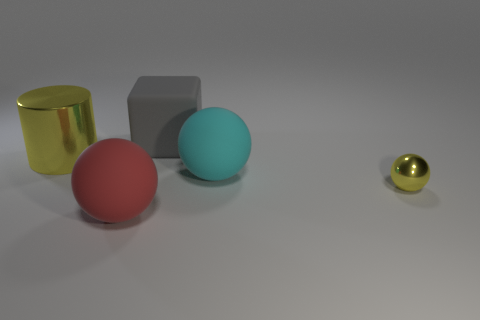What number of large things are yellow metal blocks or yellow metallic spheres?
Give a very brief answer. 0. What shape is the tiny yellow object that is made of the same material as the big yellow object?
Offer a terse response. Sphere. Does the cyan object have the same shape as the gray rubber object?
Give a very brief answer. No. What is the color of the cylinder?
Keep it short and to the point. Yellow. What number of objects are tiny things or large cyan blocks?
Your answer should be very brief. 1. Is there anything else that is the same material as the large cyan object?
Provide a succinct answer. Yes. Are there fewer large things in front of the big cyan thing than large yellow shiny cylinders?
Provide a succinct answer. No. Are there more red rubber things right of the small shiny thing than yellow cylinders on the right side of the big cube?
Your response must be concise. No. Are there any other things that are the same color as the big shiny cylinder?
Keep it short and to the point. Yes. There is a sphere that is behind the tiny yellow metal object; what is it made of?
Ensure brevity in your answer.  Rubber. 